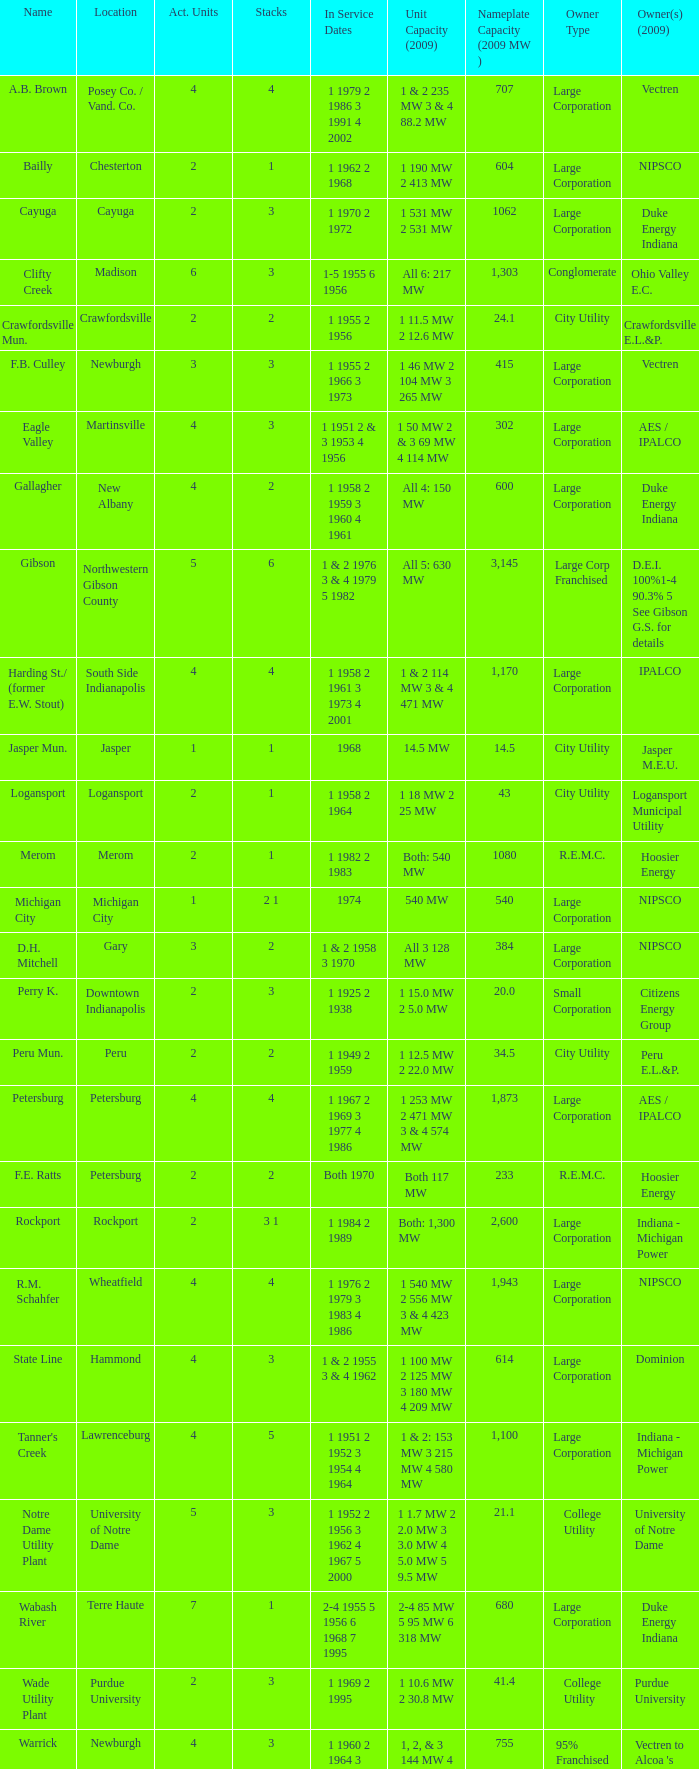Name the stacks for 1 1969 2 1995 3.0. 